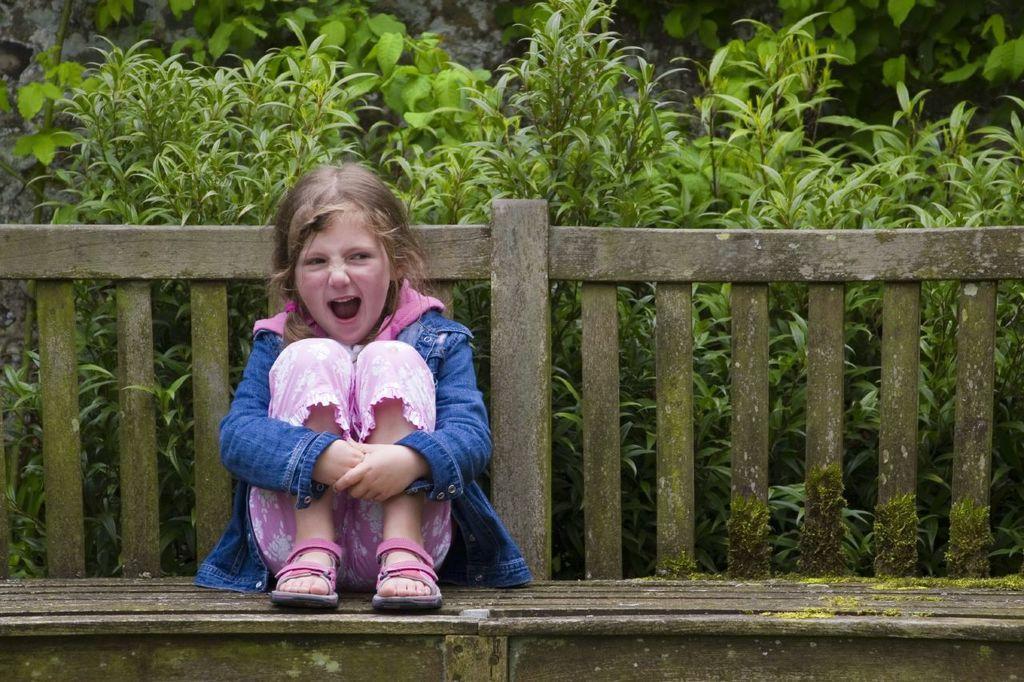Please provide a concise description of this image. A girl is sitting on the chair. She wears a pink color dress and footwear behind her there are plants. 